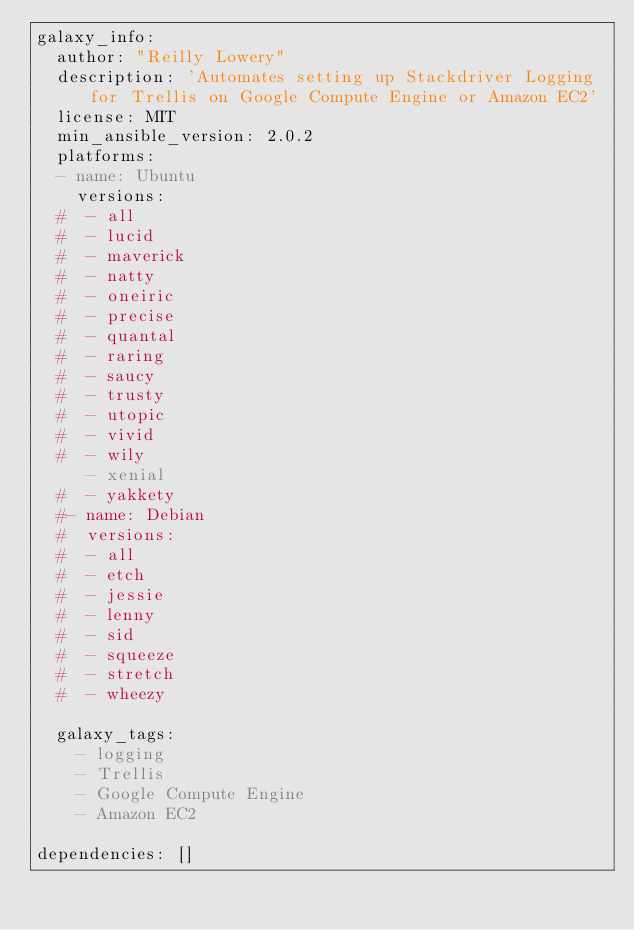<code> <loc_0><loc_0><loc_500><loc_500><_YAML_>galaxy_info:
  author: "Reilly Lowery"
  description: 'Automates setting up Stackdriver Logging for Trellis on Google Compute Engine or Amazon EC2'
  license: MIT
  min_ansible_version: 2.0.2
  platforms:
  - name: Ubuntu
    versions:
  #  - all
  #  - lucid
  #  - maverick
  #  - natty
  #  - oneiric
  #  - precise
  #  - quantal
  #  - raring
  #  - saucy
  #  - trusty
  #  - utopic
  #  - vivid
  #  - wily
     - xenial
  #  - yakkety
  #- name: Debian
  #  versions:
  #  - all
  #  - etch
  #  - jessie
  #  - lenny
  #  - sid
  #  - squeeze
  #  - stretch
  #  - wheezy
  
  galaxy_tags:
    - logging
    - Trellis
    - Google Compute Engine
    - Amazon EC2

dependencies: []</code> 